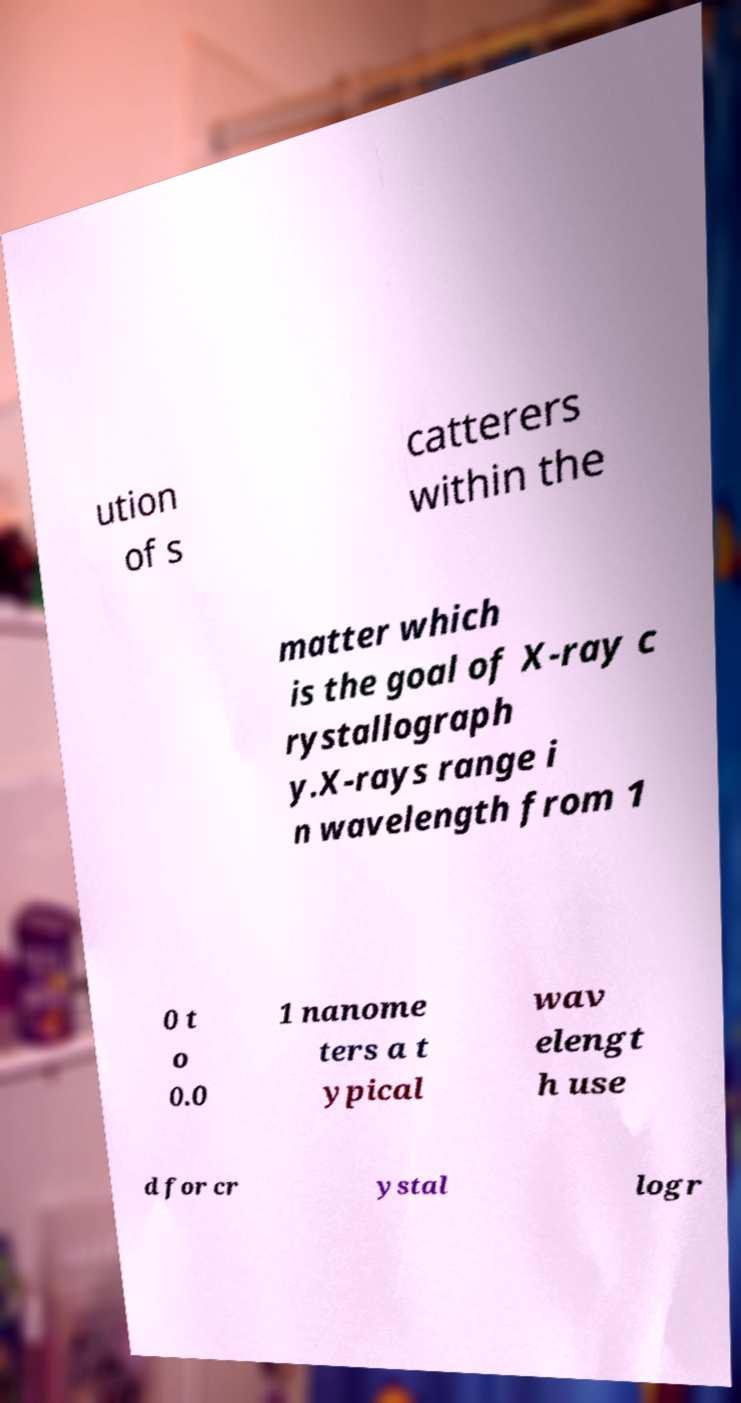What messages or text are displayed in this image? I need them in a readable, typed format. ution of s catterers within the matter which is the goal of X-ray c rystallograph y.X-rays range i n wavelength from 1 0 t o 0.0 1 nanome ters a t ypical wav elengt h use d for cr ystal logr 